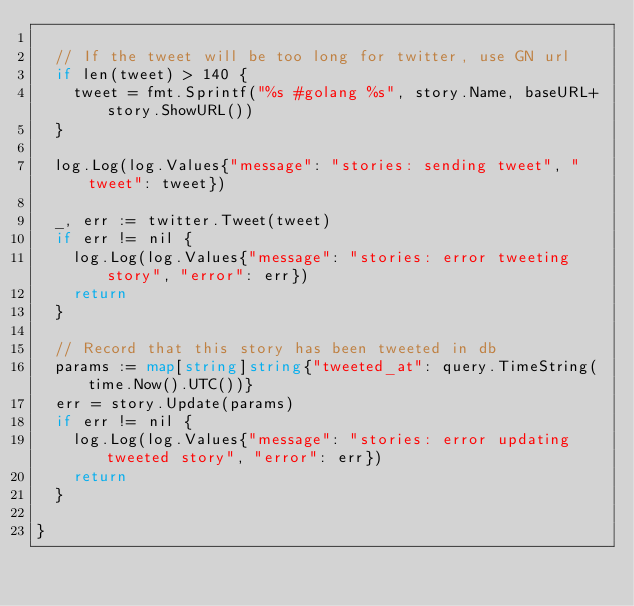Convert code to text. <code><loc_0><loc_0><loc_500><loc_500><_Go_>
	// If the tweet will be too long for twitter, use GN url
	if len(tweet) > 140 {
		tweet = fmt.Sprintf("%s #golang %s", story.Name, baseURL+story.ShowURL())
	}

	log.Log(log.Values{"message": "stories: sending tweet", "tweet": tweet})

	_, err := twitter.Tweet(tweet)
	if err != nil {
		log.Log(log.Values{"message": "stories: error tweeting story", "error": err})
		return
	}

	// Record that this story has been tweeted in db
	params := map[string]string{"tweeted_at": query.TimeString(time.Now().UTC())}
	err = story.Update(params)
	if err != nil {
		log.Log(log.Values{"message": "stories: error updating tweeted story", "error": err})
		return
	}

}
</code> 